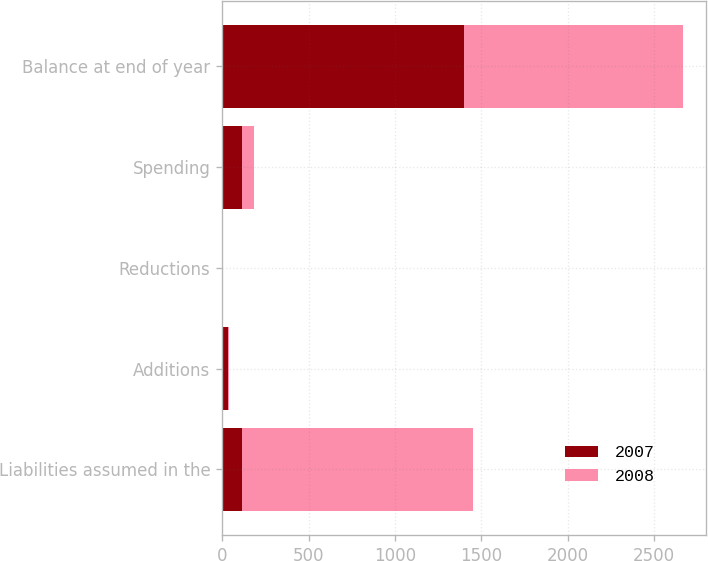Convert chart to OTSL. <chart><loc_0><loc_0><loc_500><loc_500><stacked_bar_chart><ecel><fcel>Liabilities assumed in the<fcel>Additions<fcel>Reductions<fcel>Spending<fcel>Balance at end of year<nl><fcel>2007<fcel>117<fcel>36<fcel>1<fcel>114<fcel>1401<nl><fcel>2008<fcel>1334<fcel>6<fcel>1<fcel>71<fcel>1268<nl></chart> 